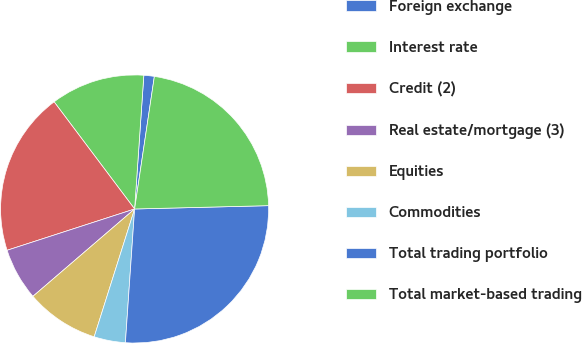Convert chart to OTSL. <chart><loc_0><loc_0><loc_500><loc_500><pie_chart><fcel>Foreign exchange<fcel>Interest rate<fcel>Credit (2)<fcel>Real estate/mortgage (3)<fcel>Equities<fcel>Commodities<fcel>Total trading portfolio<fcel>Total market-based trading<nl><fcel>1.26%<fcel>11.35%<fcel>19.73%<fcel>6.31%<fcel>8.83%<fcel>3.78%<fcel>26.49%<fcel>22.25%<nl></chart> 